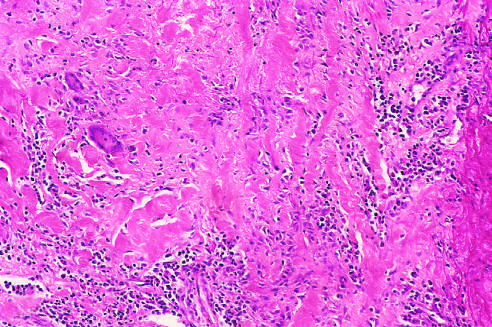s the bacteria associated with mononuclear infiltrates and giant cells?
Answer the question using a single word or phrase. No 